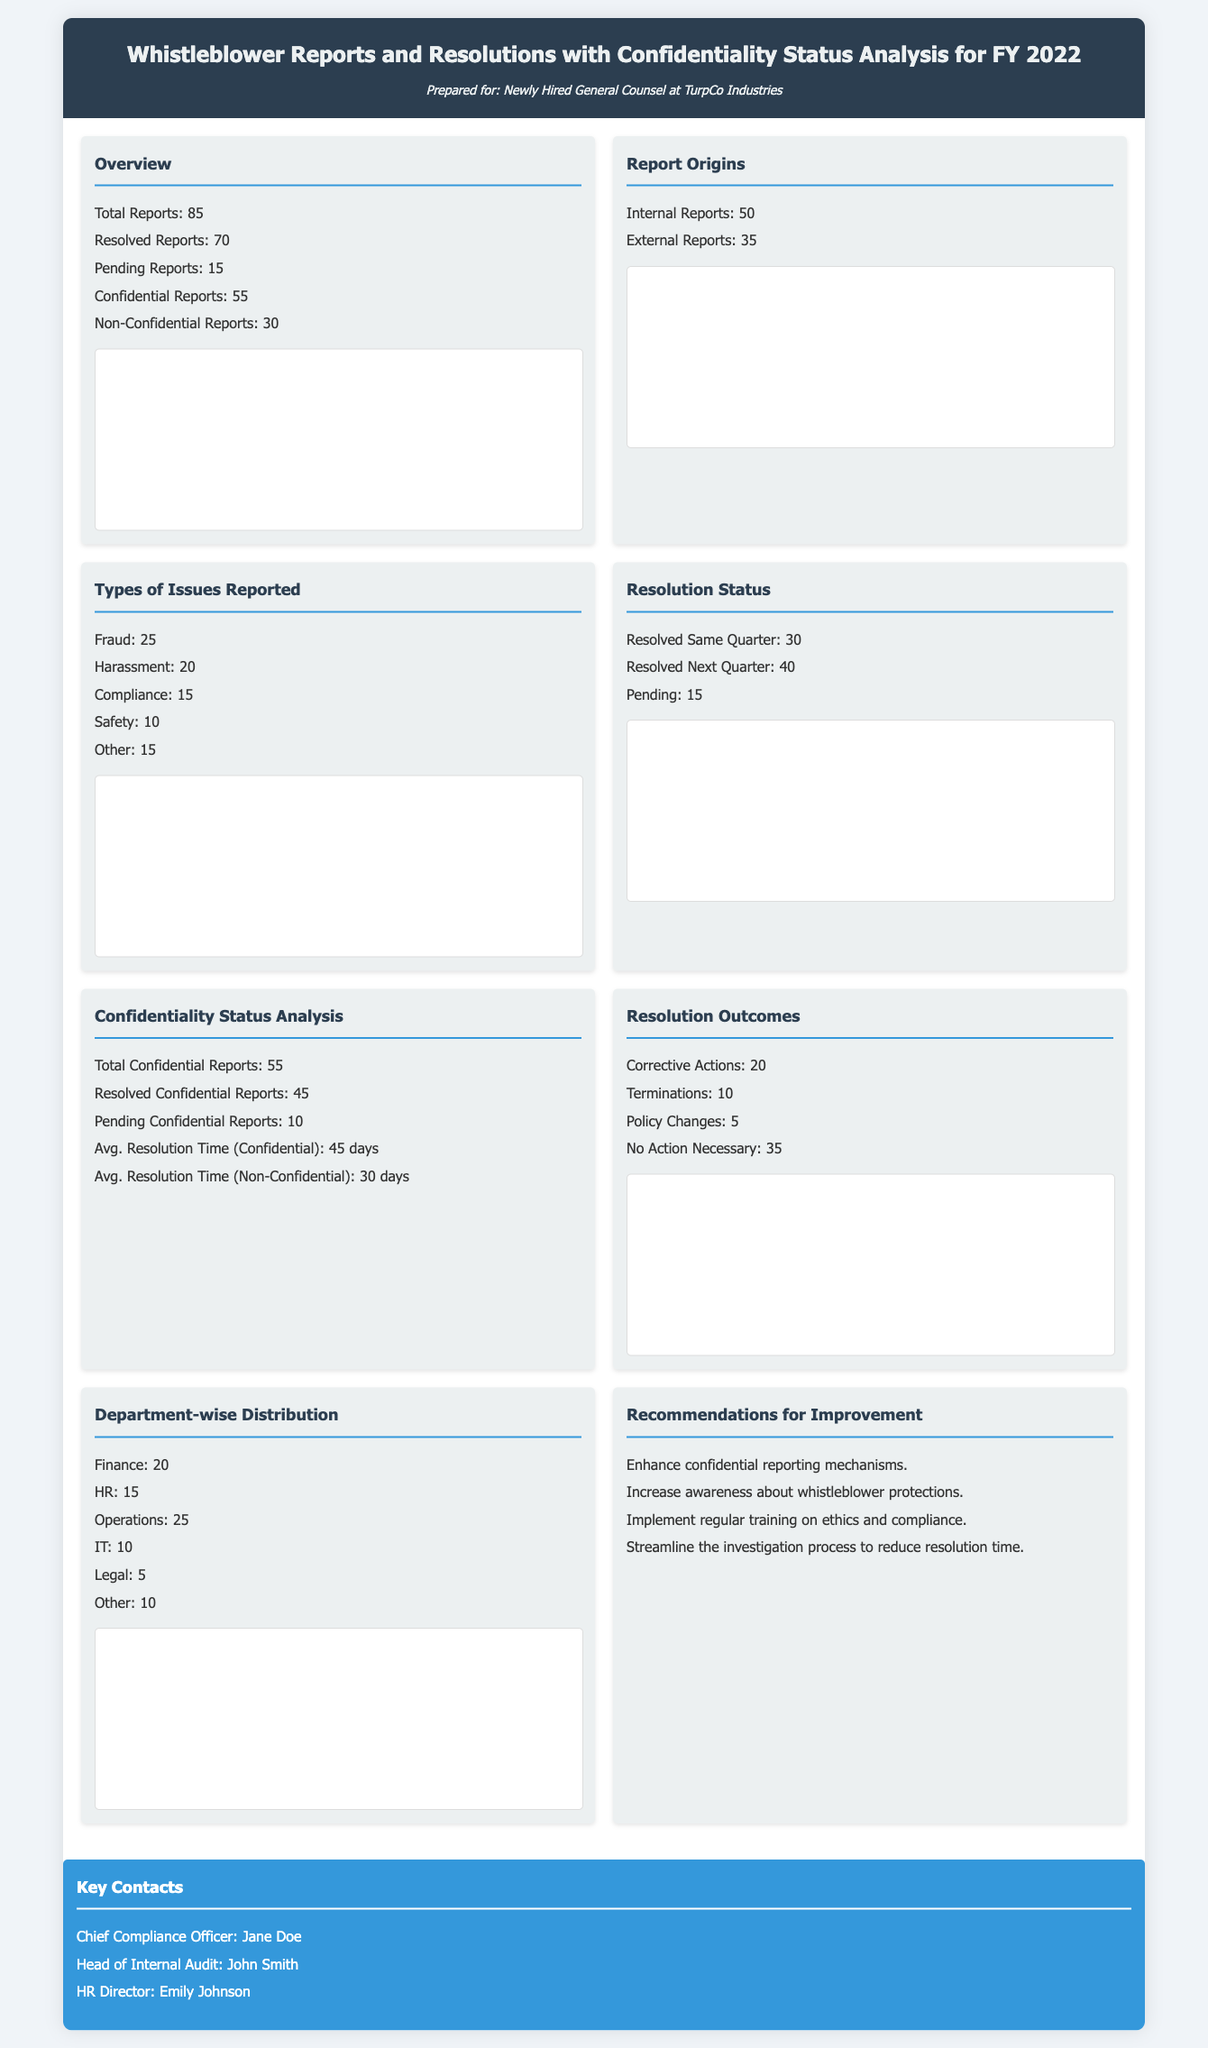what is the total number of whistleblower reports? The total number of whistleblower reports is specifically stated in the overview section of the document as 85.
Answer: 85 how many reports are pending? The number of pending reports is detailed in the overview section, which indicates there are 15 pending reports.
Answer: 15 what is the average resolution time for confidential reports? The average resolution time for confidential reports is provided in the confidentiality status analysis section, which states it is 45 days.
Answer: 45 days how many reports originated internally? The number of internal reports is specified in the report origins section, which says there are 50 internal reports.
Answer: 50 what is the largest type of issue reported? The largest type of issue reported is found in the types of issues reported section, which shows that 25 reports are related to fraud.
Answer: Fraud how many corrective actions were taken? The total number of corrective actions taken is listed in the resolution outcomes section as 20.
Answer: 20 what percentage of reports were resolved? The percentage of reports resolved can be calculated from the overview section, where 70 reports are resolved out of 85 total reports, which is approximately 82.35%.
Answer: 82.35% how many reports were classified as non-confidential? The document mentions in the overview section that there are 30 non-confidential reports.
Answer: 30 who is the Chief Compliance Officer listed in key contacts? The Chief Compliance Officer is named in the key contacts section, which identifies Jane Doe as the individual in that role.
Answer: Jane Doe 